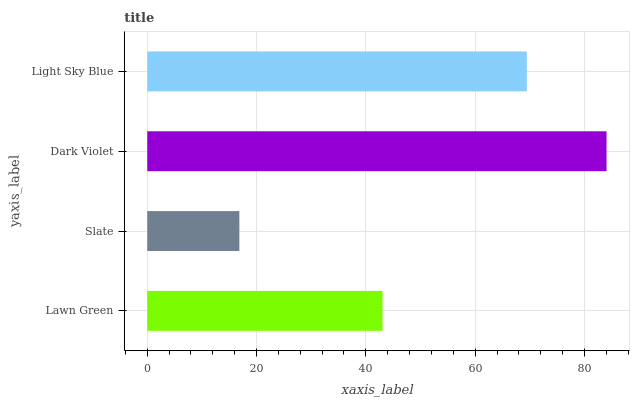Is Slate the minimum?
Answer yes or no. Yes. Is Dark Violet the maximum?
Answer yes or no. Yes. Is Dark Violet the minimum?
Answer yes or no. No. Is Slate the maximum?
Answer yes or no. No. Is Dark Violet greater than Slate?
Answer yes or no. Yes. Is Slate less than Dark Violet?
Answer yes or no. Yes. Is Slate greater than Dark Violet?
Answer yes or no. No. Is Dark Violet less than Slate?
Answer yes or no. No. Is Light Sky Blue the high median?
Answer yes or no. Yes. Is Lawn Green the low median?
Answer yes or no. Yes. Is Dark Violet the high median?
Answer yes or no. No. Is Light Sky Blue the low median?
Answer yes or no. No. 